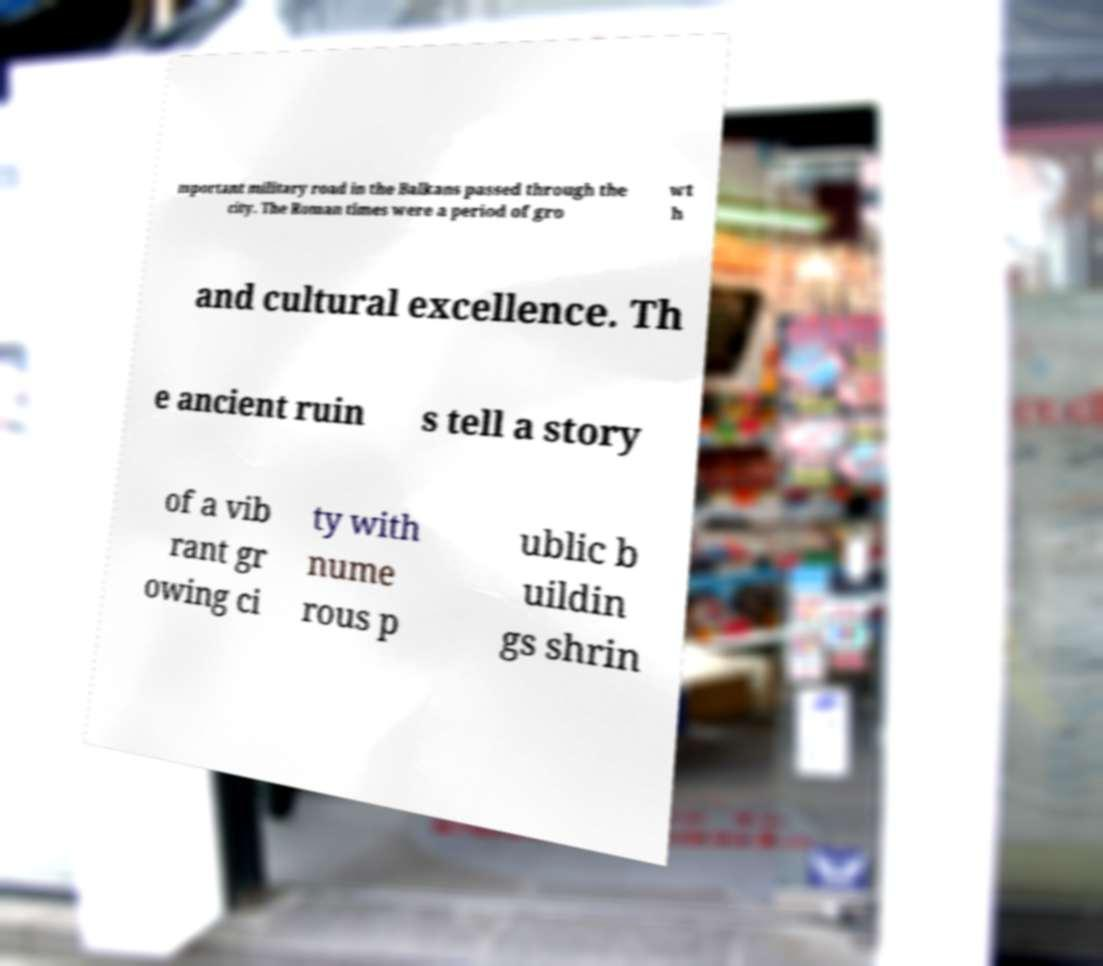Can you accurately transcribe the text from the provided image for me? mportant military road in the Balkans passed through the city. The Roman times were a period of gro wt h and cultural excellence. Th e ancient ruin s tell a story of a vib rant gr owing ci ty with nume rous p ublic b uildin gs shrin 